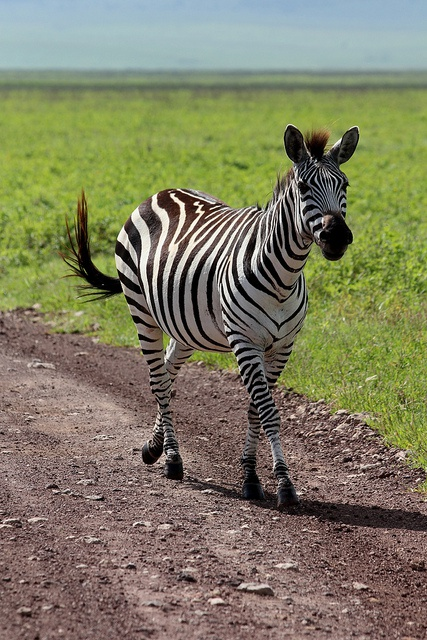Describe the objects in this image and their specific colors. I can see a zebra in lightblue, black, gray, lightgray, and darkgray tones in this image. 